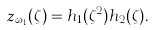Convert formula to latex. <formula><loc_0><loc_0><loc_500><loc_500>z _ { \omega _ { 1 } } ( \zeta ) = h _ { 1 } ( \zeta ^ { 2 } ) h _ { 2 } ( \zeta ) .</formula> 